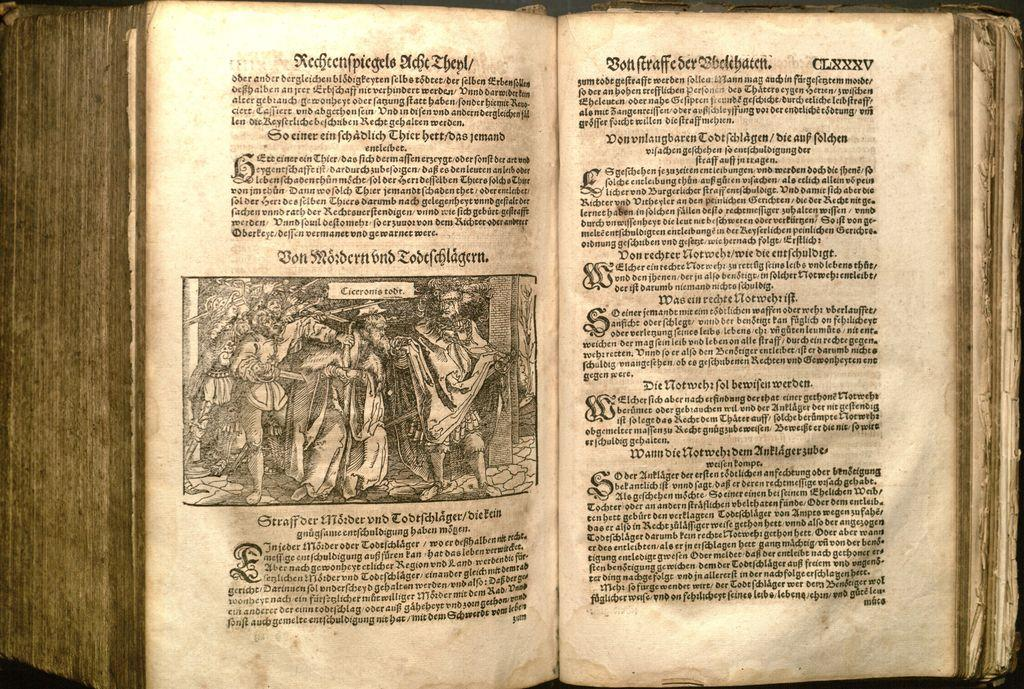<image>
Offer a succinct explanation of the picture presented. A very old open book in which the text is not recognisable as modern English. 